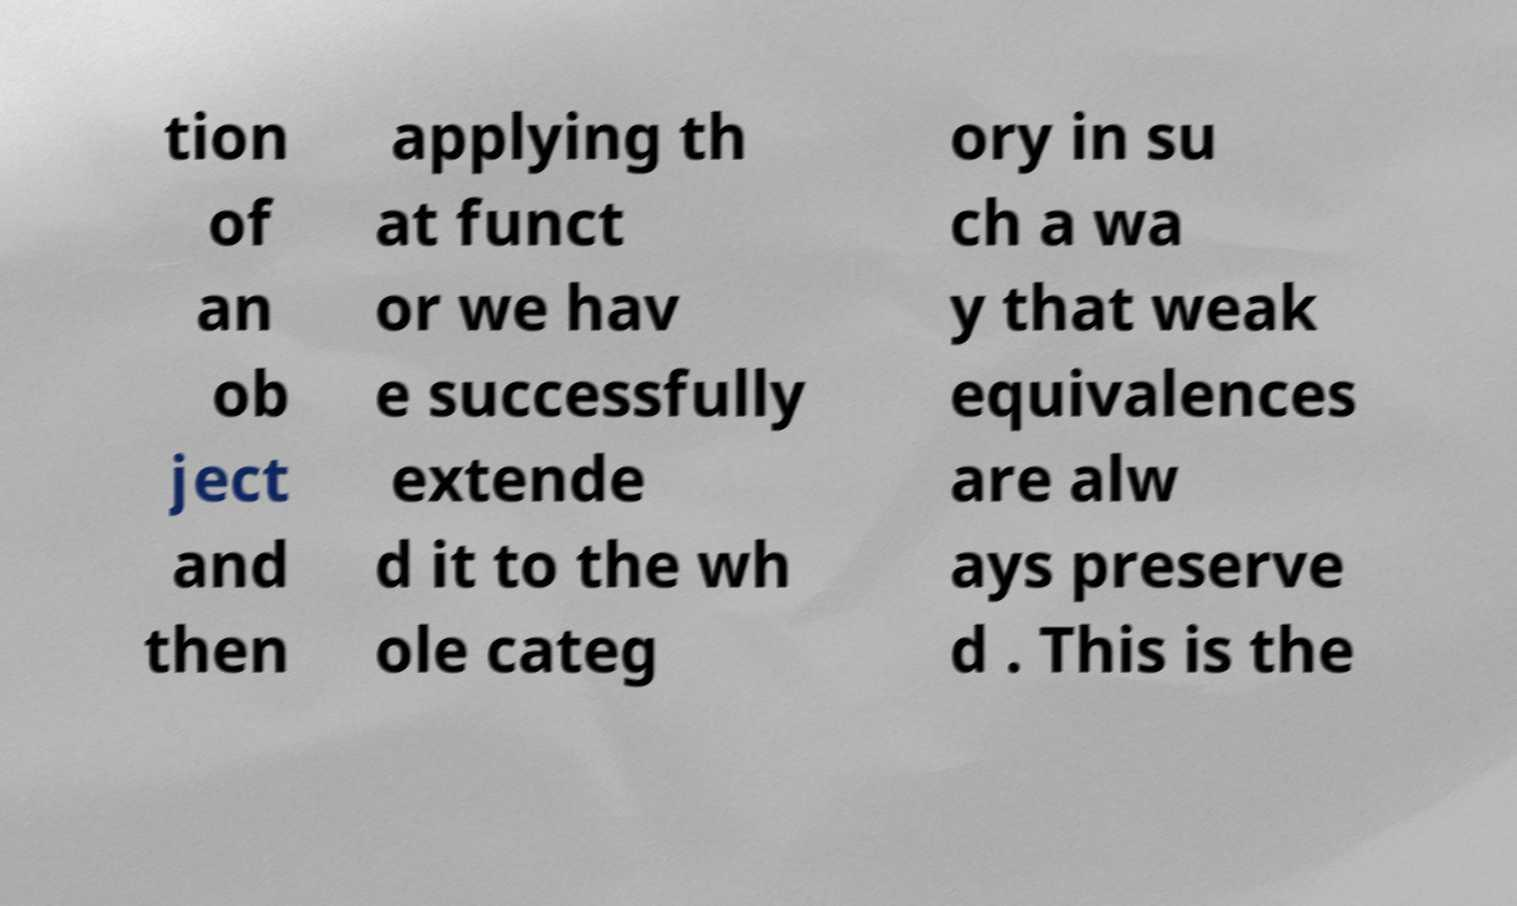Please read and relay the text visible in this image. What does it say? tion of an ob ject and then applying th at funct or we hav e successfully extende d it to the wh ole categ ory in su ch a wa y that weak equivalences are alw ays preserve d . This is the 